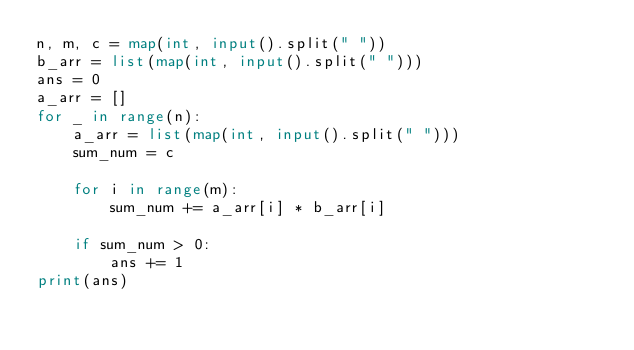<code> <loc_0><loc_0><loc_500><loc_500><_Python_>n, m, c = map(int, input().split(" "))
b_arr = list(map(int, input().split(" ")))
ans = 0
a_arr = []
for _ in range(n):
    a_arr = list(map(int, input().split(" ")))
    sum_num = c

    for i in range(m):
        sum_num += a_arr[i] * b_arr[i]

    if sum_num > 0:
        ans += 1
print(ans)
</code> 